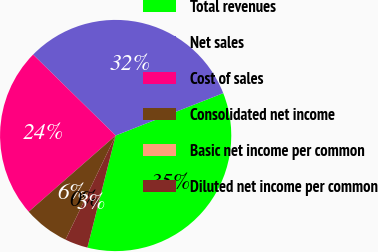Convert chart. <chart><loc_0><loc_0><loc_500><loc_500><pie_chart><fcel>Total revenues<fcel>Net sales<fcel>Cost of sales<fcel>Consolidated net income<fcel>Basic net income per common<fcel>Diluted net income per common<nl><fcel>34.9%<fcel>31.69%<fcel>23.79%<fcel>6.41%<fcel>0.0%<fcel>3.21%<nl></chart> 